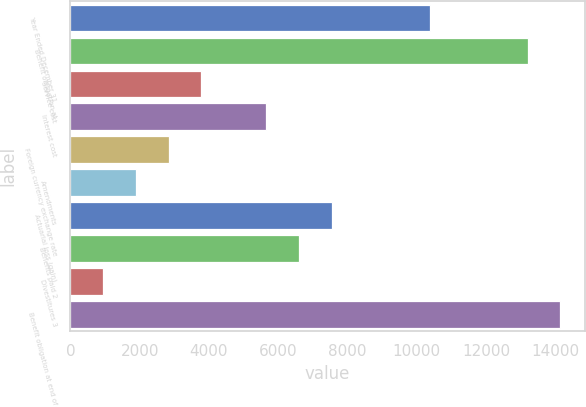Convert chart to OTSL. <chart><loc_0><loc_0><loc_500><loc_500><bar_chart><fcel>Year Ended December 31<fcel>Benefit obligation at<fcel>Service cost<fcel>Interest cost<fcel>Foreign currency exchange rate<fcel>Amendments<fcel>Actuarial loss (gain)<fcel>Benefits paid 2<fcel>Divestitures 3<fcel>Benefit obligation at end of<nl><fcel>10370.4<fcel>13197.6<fcel>3773.6<fcel>5658.4<fcel>2831.2<fcel>1888.8<fcel>7543.2<fcel>6600.8<fcel>946.4<fcel>14140<nl></chart> 